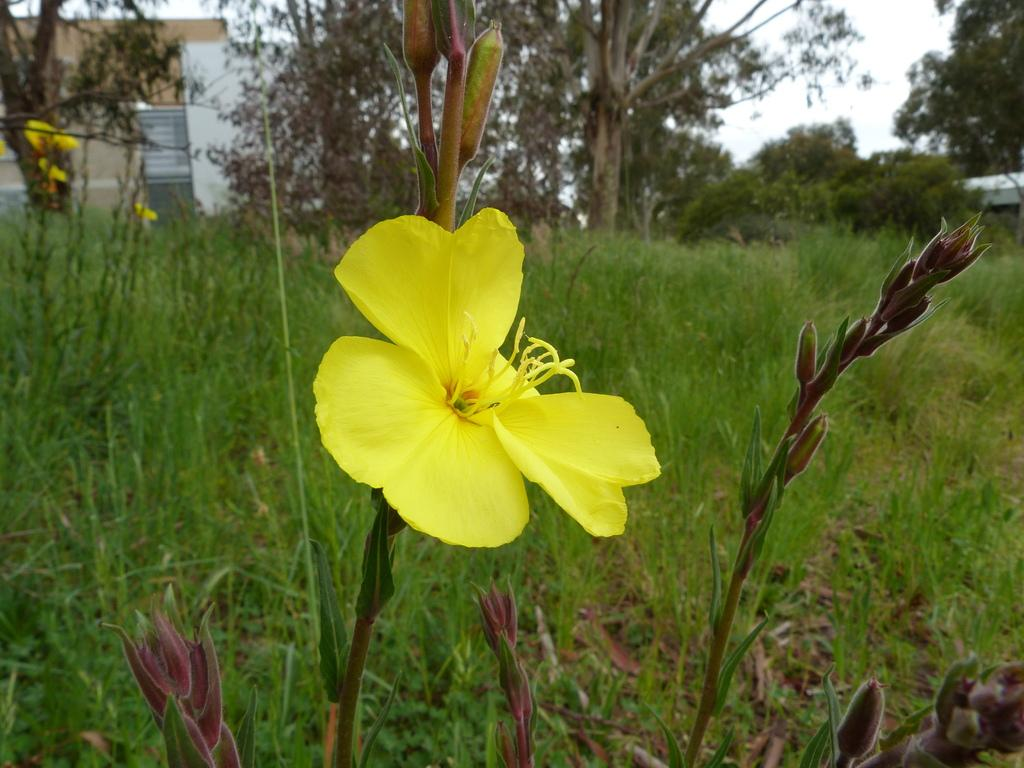What is the main subject in the foreground of the picture? There is a yellow color flower in the foreground of the picture. What can be seen in the background of the picture? There is green grass, trees, and a house in the background of the picture. What type of protest is happening in the background of the picture? There is no protest present in the image; it features a yellow flower in the foreground and green grass, trees, and a house in the background. 